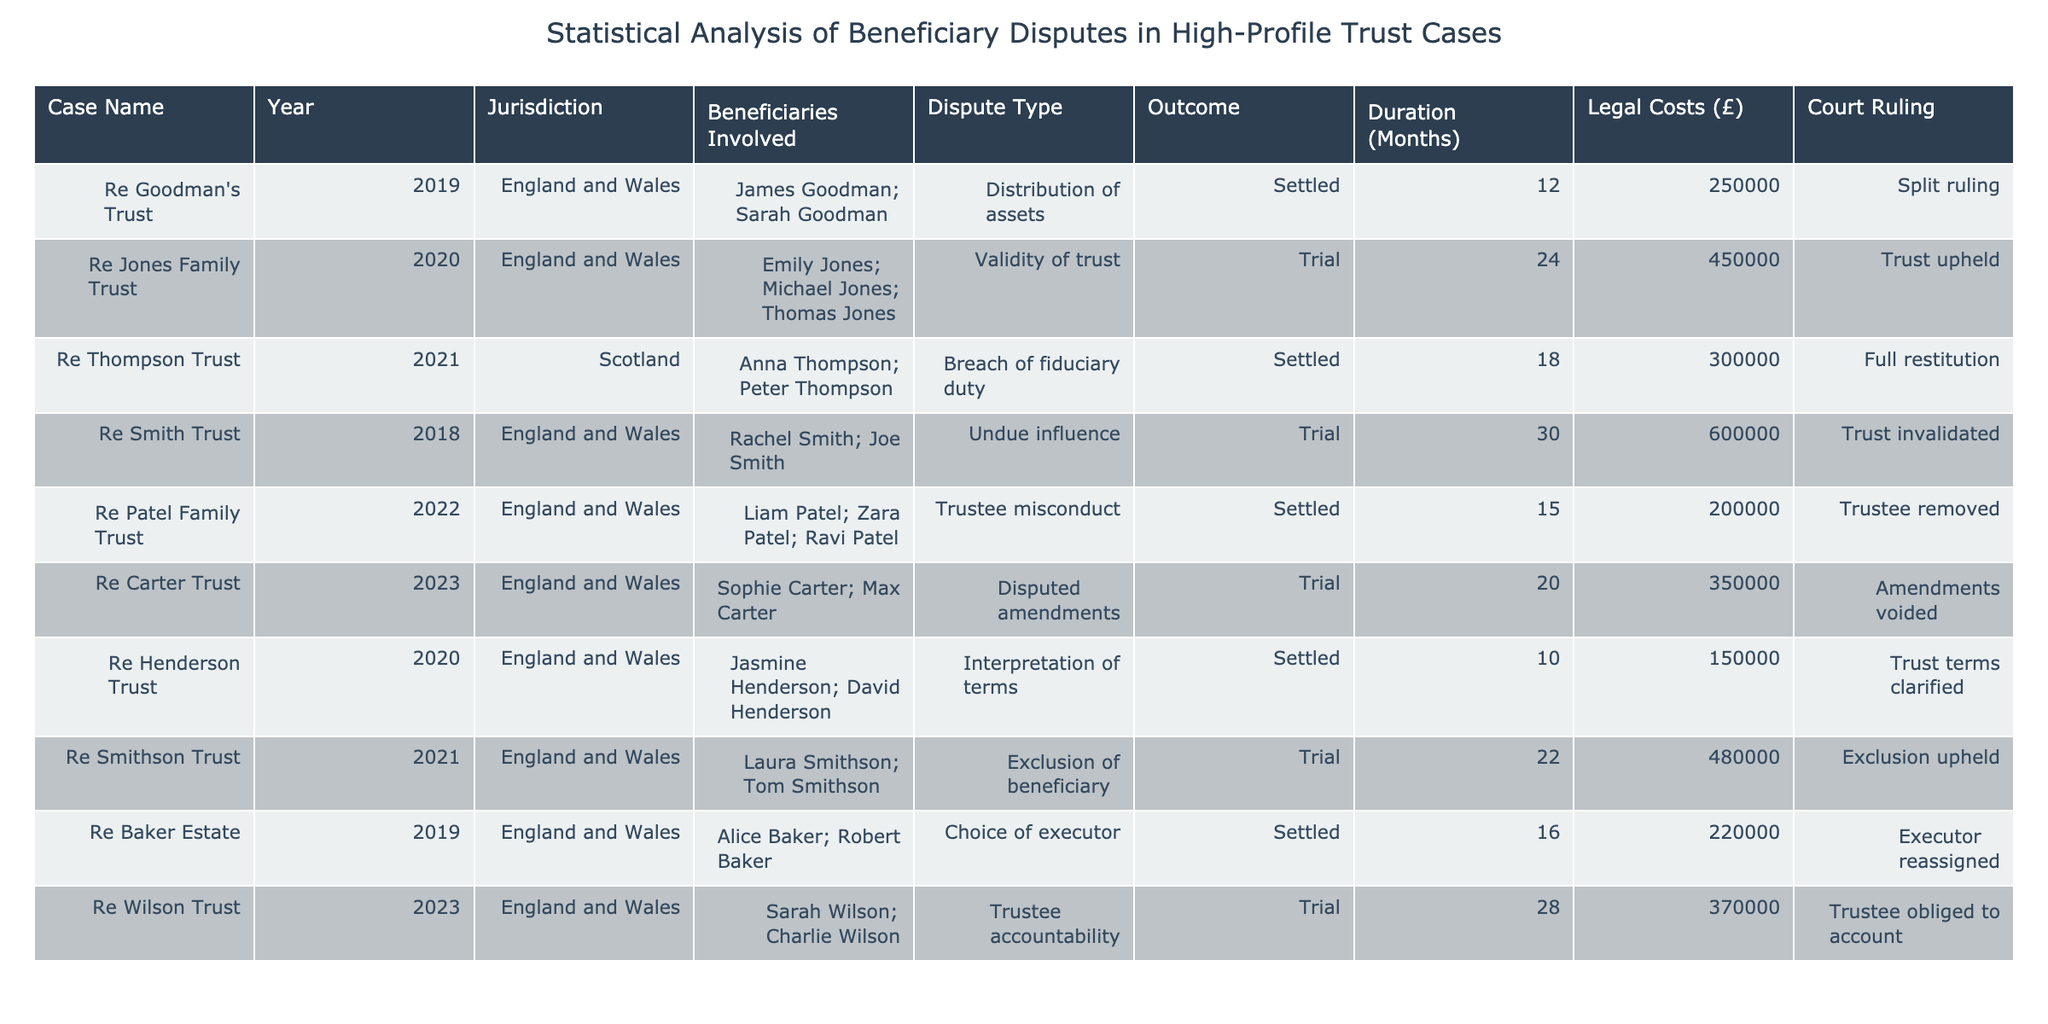What was the total legal cost incurred in all the cases from England and Wales? To find the total legal cost, we need to list the legal costs for each case from England and Wales: 250000 (Goodman's Trust) + 450000 (Jones Family Trust) + 600000 (Smith Trust) + 200000 (Patel Family Trust) + 150000 (Henderson Trust) + 480000 (Smithson Trust) + 220000 (Baker Estate) + 370000 (Wilson Trust). Adding these together gives a total of 250000 + 450000 + 600000 + 200000 + 150000 + 480000 + 220000 + 370000 = 2820000.
Answer: 2820000 Which case had the longest duration and how long did it last? The duration is listed alongside each case. The maximum duration is 30 months, which is associated with the Smith Trust case (undue influence). None of the other cases exceed this duration.
Answer: 30 months, Smith Trust Was there any case in which the trust was invalidated? By reviewing the outcomes of each case, the Smith Trust case resulted in the trust being invalidated. This is the only instance found in the data set.
Answer: Yes, Smith Trust How many dispute types were resolved in trials versus settlements? First, count the cases categorized as "Trial" and "Settled." There are 4 cases resolved through trial: Jones Family Trust, Smith Trust, Carter Trust, and Wilson Trust. There are 5 cases settled: Goodman's Trust, Thompson Trust, Patel Family Trust, Henderson Trust, and Baker Estate. Thus, the number of dispute types resolved in trials is 4, while those settled is 5.
Answer: Trials: 4, Settlements: 5 What proportion of cases resulted in the trustee being removed? From the table, only the Patel Family Trust case resulted in the trustee being removed. There are a total of 10 cases. Hence, the proportion is 1 removed / 10 total = 0.1 or 10%.
Answer: 10% 